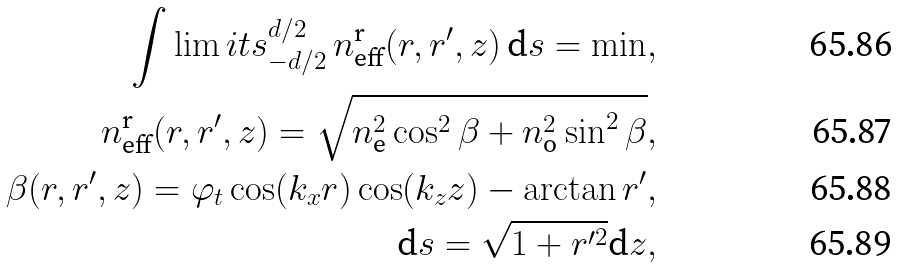Convert formula to latex. <formula><loc_0><loc_0><loc_500><loc_500>\int \lim i t s _ { - d / 2 } ^ { d / 2 } \, n _ { \text {eff} } ^ { \text {r} } ( r , r ^ { \prime } , z ) \, \text {d} s = \min , \\ n _ { \text {eff} } ^ { \text {r} } ( r , r ^ { \prime } , z ) = \sqrt { n _ { \text {e} } ^ { 2 } \cos ^ { 2 } \beta + n _ { \text {o} } ^ { 2 } \sin ^ { 2 } \beta } , \\ \beta ( r , r ^ { \prime } , z ) = \varphi _ { t } \cos ( k _ { x } r ) \cos ( k _ { z } z ) - \arctan r ^ { \prime } , \\ \text {d} s = \sqrt { 1 + r ^ { \prime 2 } } \text {d} z ,</formula> 